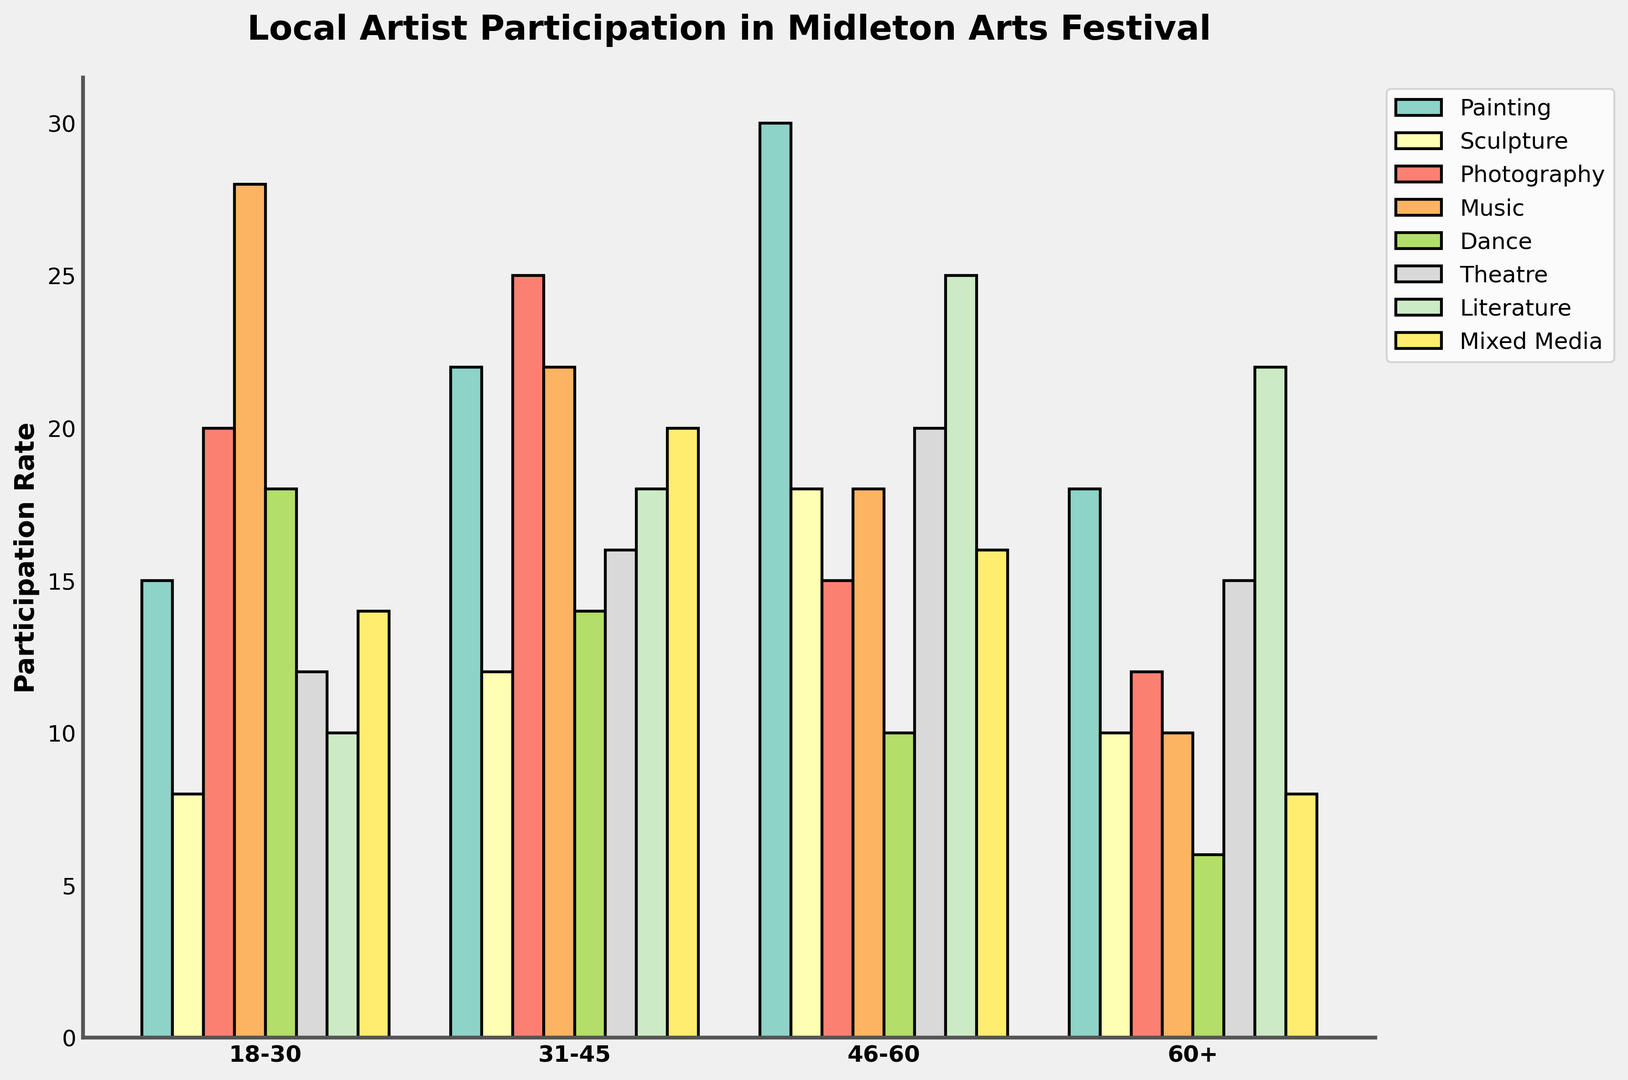Which category has the highest participation rate for the age group 18-30? Look at the bar heights for each category in the age group 18-30. The Music category has the tallest bar.
Answer: Music Between the age groups 31-45 and 46-60, which one has higher participation in Theatre? Compare the heights of the Theatre bars for the age groups 31-45 and 46-60. The bar for 46-60 is higher.
Answer: 46-60 What is the total participation of Painting for all age groups combined? Sum the participation rates for Painting across all age groups: 15 (18-30) + 22 (31-45) + 30 (46-60) + 18 (60+). The total is 85.
Answer: 85 Which age group has the lowest participation in Dance? Look at the bars for the Dance category across all age groups. The 60+ age group has the shortest bar.
Answer: 60+ Is the participation in Literature higher or lower than in Mixed Media for the age group 31-45? Compare the bars for Literature and Mixed Media in the age group 31-45. The bar for Literature is higher.
Answer: Higher What is the average participation rate in Photography across all age groups? Sum the participation rates for Photography: 20 (18-30) + 25 (31-45) + 15 (46-60) + 12 (60+). The total is 72. Divide by the number of age groups which is 4. The average is 72/4 = 18.
Answer: 18 Compare the participation rates in Sculpture between the age group 18-30 and the age group 60+. Which is higher and by how much? Sculpture participation is 8 for age group 18-30 and 10 for age group 60+. 10 - 8 = 2. The 60+ age group is higher by 2.
Answer: 60+ by 2 What is the combined participation rate for the 60+ age group in Dance and Theatre? Add the participation rates for Dance and Theatre in the 60+ age group: 6 (Dance) + 15 (Theatre). The total is 21.
Answer: 21 Which category shows the most significant increase in participation rate from age group 18-30 to age group 31-45? Compare the increase in bar heights for all categories between the age groups 18-30 and 31-45. Literature increases from 10 to 18, the highest nominal increase is 8.
Answer: Literature 